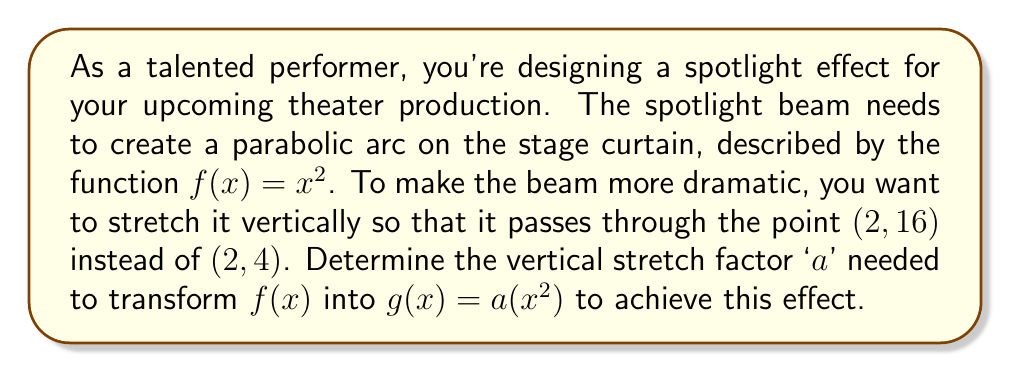Give your solution to this math problem. To solve this problem, we'll follow these steps:

1) The original function $f(x) = x^2$ passes through the point (2, 4) because $f(2) = 2^2 = 4$.

2) We want to stretch $f(x)$ vertically to create $g(x) = a(x^2)$ so that it passes through (2, 16).

3) We can find the stretch factor 'a' by substituting the new point into $g(x)$:

   $g(2) = 16$
   $a(2^2) = 16$
   $a(4) = 16$

4) Now we can solve for 'a':

   $4a = 16$
   $a = 16 / 4 = 4$

5) Therefore, the vertical stretch factor is 4, meaning the function has been stretched to 4 times its original height.

6) We can verify this by comparing the y-coordinates of $f(2)$ and $g(2)$:
   $f(2) = 4$
   $g(2) = 4(2^2) = 4(4) = 16$

   Indeed, the y-coordinate at x = 2 has increased from 4 to 16, which is 4 times larger.
Answer: The vertical stretch factor 'a' needed to transform $f(x) = x^2$ into $g(x) = a(x^2)$ so that it passes through the point (2, 16) is $a = 4$. 